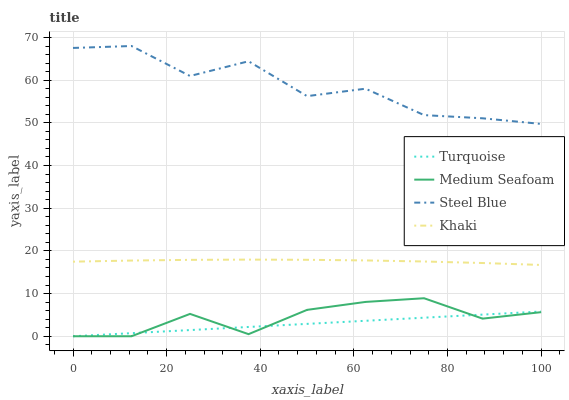Does Turquoise have the minimum area under the curve?
Answer yes or no. Yes. Does Steel Blue have the maximum area under the curve?
Answer yes or no. Yes. Does Khaki have the minimum area under the curve?
Answer yes or no. No. Does Khaki have the maximum area under the curve?
Answer yes or no. No. Is Turquoise the smoothest?
Answer yes or no. Yes. Is Steel Blue the roughest?
Answer yes or no. Yes. Is Khaki the smoothest?
Answer yes or no. No. Is Khaki the roughest?
Answer yes or no. No. Does Turquoise have the lowest value?
Answer yes or no. Yes. Does Khaki have the lowest value?
Answer yes or no. No. Does Steel Blue have the highest value?
Answer yes or no. Yes. Does Khaki have the highest value?
Answer yes or no. No. Is Turquoise less than Khaki?
Answer yes or no. Yes. Is Steel Blue greater than Turquoise?
Answer yes or no. Yes. Does Medium Seafoam intersect Turquoise?
Answer yes or no. Yes. Is Medium Seafoam less than Turquoise?
Answer yes or no. No. Is Medium Seafoam greater than Turquoise?
Answer yes or no. No. Does Turquoise intersect Khaki?
Answer yes or no. No. 